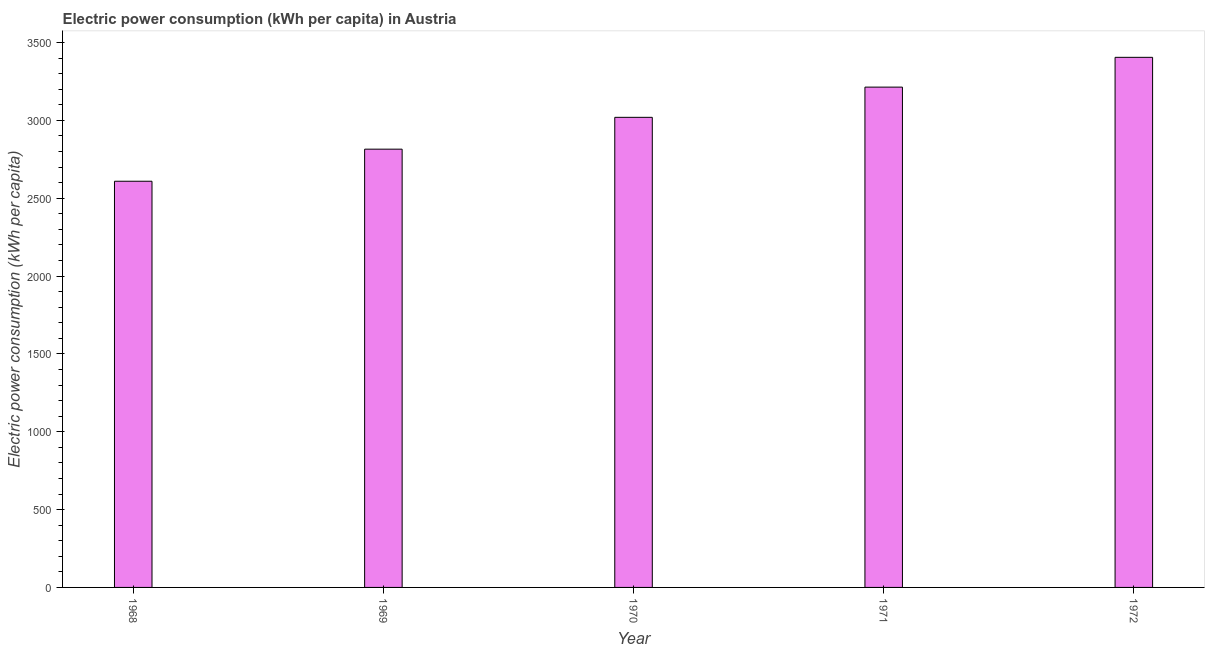Does the graph contain any zero values?
Offer a very short reply. No. Does the graph contain grids?
Offer a very short reply. No. What is the title of the graph?
Ensure brevity in your answer.  Electric power consumption (kWh per capita) in Austria. What is the label or title of the Y-axis?
Provide a short and direct response. Electric power consumption (kWh per capita). What is the electric power consumption in 1968?
Keep it short and to the point. 2608.62. Across all years, what is the maximum electric power consumption?
Your answer should be compact. 3404.47. Across all years, what is the minimum electric power consumption?
Provide a short and direct response. 2608.62. In which year was the electric power consumption minimum?
Offer a terse response. 1968. What is the sum of the electric power consumption?
Ensure brevity in your answer.  1.51e+04. What is the difference between the electric power consumption in 1969 and 1971?
Your answer should be very brief. -398.47. What is the average electric power consumption per year?
Ensure brevity in your answer.  3012. What is the median electric power consumption?
Keep it short and to the point. 3019.12. In how many years, is the electric power consumption greater than 400 kWh per capita?
Provide a short and direct response. 5. Do a majority of the years between 1968 and 1969 (inclusive) have electric power consumption greater than 500 kWh per capita?
Keep it short and to the point. Yes. What is the ratio of the electric power consumption in 1969 to that in 1970?
Your response must be concise. 0.93. Is the difference between the electric power consumption in 1968 and 1971 greater than the difference between any two years?
Provide a succinct answer. No. What is the difference between the highest and the second highest electric power consumption?
Provide a succinct answer. 191.34. Is the sum of the electric power consumption in 1969 and 1970 greater than the maximum electric power consumption across all years?
Provide a short and direct response. Yes. What is the difference between the highest and the lowest electric power consumption?
Provide a short and direct response. 795.84. In how many years, is the electric power consumption greater than the average electric power consumption taken over all years?
Provide a succinct answer. 3. How many bars are there?
Make the answer very short. 5. Are all the bars in the graph horizontal?
Keep it short and to the point. No. What is the difference between two consecutive major ticks on the Y-axis?
Keep it short and to the point. 500. What is the Electric power consumption (kWh per capita) of 1968?
Offer a very short reply. 2608.62. What is the Electric power consumption (kWh per capita) of 1969?
Your response must be concise. 2814.65. What is the Electric power consumption (kWh per capita) in 1970?
Your answer should be very brief. 3019.12. What is the Electric power consumption (kWh per capita) of 1971?
Provide a succinct answer. 3213.13. What is the Electric power consumption (kWh per capita) of 1972?
Offer a very short reply. 3404.47. What is the difference between the Electric power consumption (kWh per capita) in 1968 and 1969?
Provide a short and direct response. -206.03. What is the difference between the Electric power consumption (kWh per capita) in 1968 and 1970?
Ensure brevity in your answer.  -410.49. What is the difference between the Electric power consumption (kWh per capita) in 1968 and 1971?
Provide a succinct answer. -604.5. What is the difference between the Electric power consumption (kWh per capita) in 1968 and 1972?
Give a very brief answer. -795.84. What is the difference between the Electric power consumption (kWh per capita) in 1969 and 1970?
Offer a terse response. -204.46. What is the difference between the Electric power consumption (kWh per capita) in 1969 and 1971?
Your answer should be very brief. -398.47. What is the difference between the Electric power consumption (kWh per capita) in 1969 and 1972?
Offer a terse response. -589.81. What is the difference between the Electric power consumption (kWh per capita) in 1970 and 1971?
Offer a very short reply. -194.01. What is the difference between the Electric power consumption (kWh per capita) in 1970 and 1972?
Provide a short and direct response. -385.35. What is the difference between the Electric power consumption (kWh per capita) in 1971 and 1972?
Offer a terse response. -191.34. What is the ratio of the Electric power consumption (kWh per capita) in 1968 to that in 1969?
Offer a very short reply. 0.93. What is the ratio of the Electric power consumption (kWh per capita) in 1968 to that in 1970?
Your response must be concise. 0.86. What is the ratio of the Electric power consumption (kWh per capita) in 1968 to that in 1971?
Make the answer very short. 0.81. What is the ratio of the Electric power consumption (kWh per capita) in 1968 to that in 1972?
Your answer should be very brief. 0.77. What is the ratio of the Electric power consumption (kWh per capita) in 1969 to that in 1970?
Provide a short and direct response. 0.93. What is the ratio of the Electric power consumption (kWh per capita) in 1969 to that in 1971?
Your answer should be compact. 0.88. What is the ratio of the Electric power consumption (kWh per capita) in 1969 to that in 1972?
Ensure brevity in your answer.  0.83. What is the ratio of the Electric power consumption (kWh per capita) in 1970 to that in 1971?
Keep it short and to the point. 0.94. What is the ratio of the Electric power consumption (kWh per capita) in 1970 to that in 1972?
Offer a terse response. 0.89. What is the ratio of the Electric power consumption (kWh per capita) in 1971 to that in 1972?
Give a very brief answer. 0.94. 